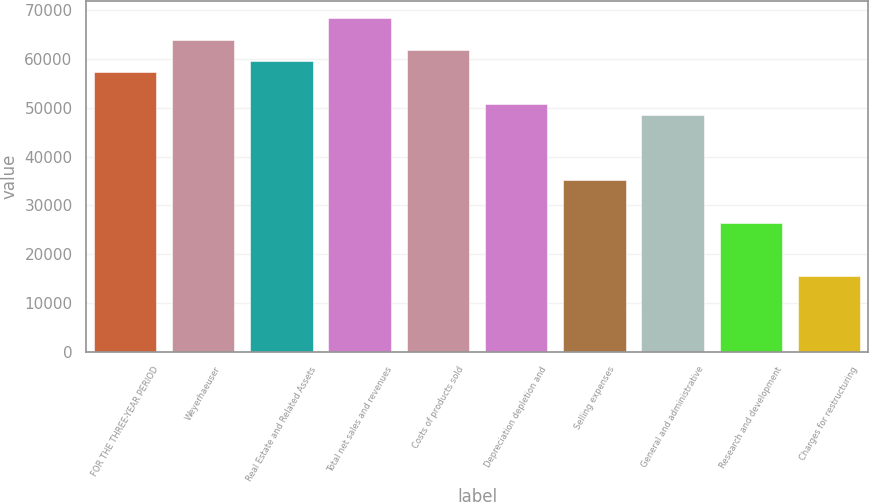Convert chart. <chart><loc_0><loc_0><loc_500><loc_500><bar_chart><fcel>FOR THE THREE-YEAR PERIOD<fcel>Weyerhaeuser<fcel>Real Estate and Related Assets<fcel>Total net sales and revenues<fcel>Costs of products sold<fcel>Depreciation depletion and<fcel>Selling expenses<fcel>General and administrative<fcel>Research and development<fcel>Charges for restructuring<nl><fcel>57318.4<fcel>63932<fcel>59523<fcel>68341.1<fcel>61727.5<fcel>50704.9<fcel>35273.2<fcel>48500.3<fcel>26455<fcel>15432.4<nl></chart> 